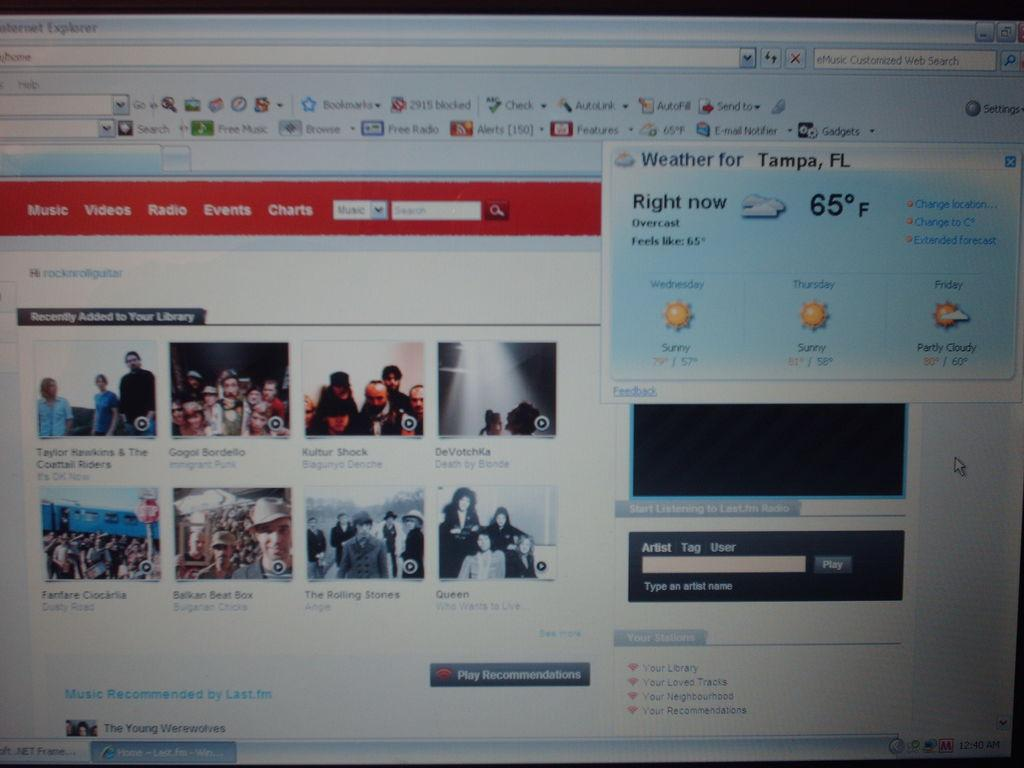<image>
Provide a brief description of the given image. According to the news website, it is currently 65* in Tampa, FL. 